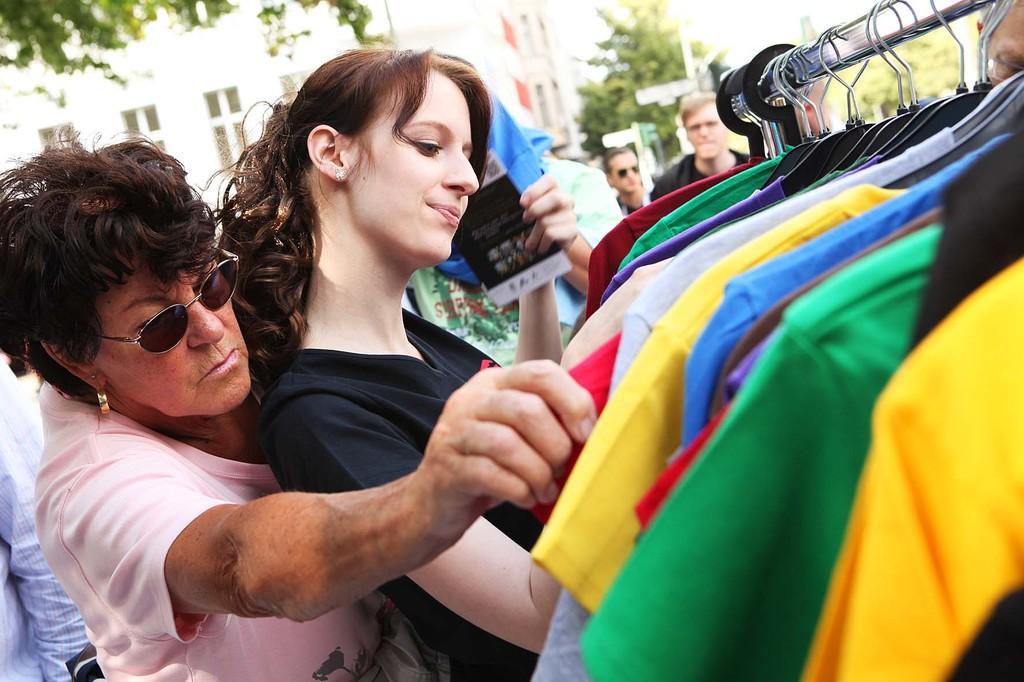Describe this image in one or two sentences. In this image I can see on the left side an old woman is trying to select the clothes. In the middle a beautiful girl is there, she wore black color top. On the right side there are t-shirts that are changed to this hanger, at the back side there are trees and buildings. 